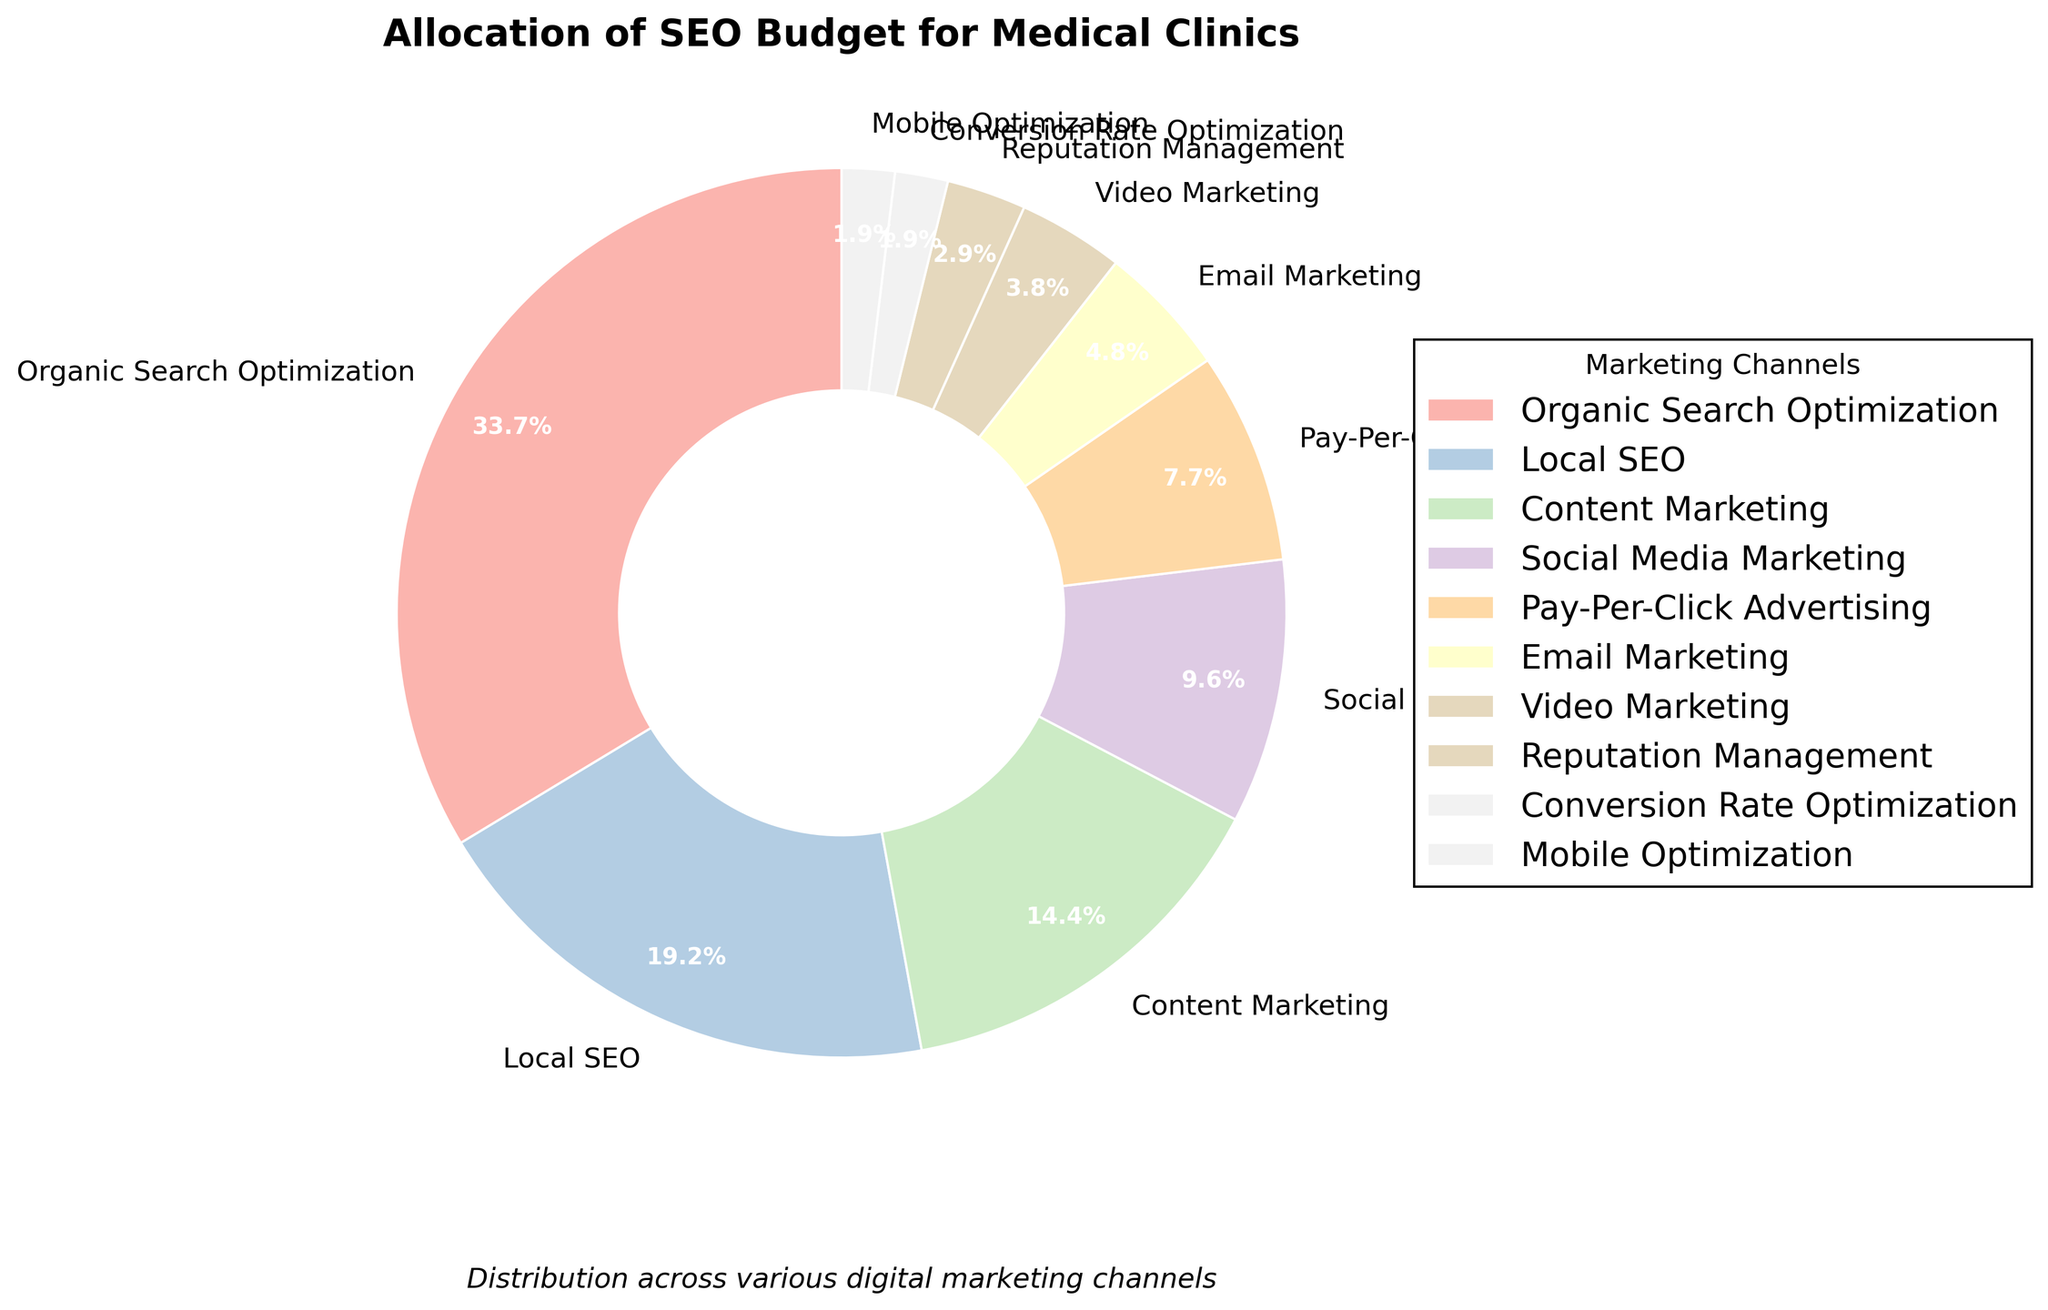What is the largest allocation percentage and which marketing channel does it correspond to? The largest allocation percentage is directly visible on the pie chart and can be seen in the section with the highest numerical label. This corresponds to Organic Search Optimization at 35%.
Answer: 35%, Organic Search Optimization Which marketing channel has the smallest allocation percentage? By looking at the smallest segment in the pie chart, we can see that the segment corresponding to the smallest percentage has a label of 2%. There are two channels with this percentage: Conversion Rate Optimization and Mobile Optimization.
Answer: Conversion Rate Optimization, Mobile Optimization How much budget, in percentage, is allocated to Local SEO and Content Marketing combined? To find the combined allocation, sum the percentages for Local SEO (20%) and Content Marketing (15%). 20% + 15% = 35%
Answer: 35% Does Social Media Marketing receive a higher budget allocation than Email Marketing? By examining the pie chart, we can compare the percentages for Social Media Marketing (10%) and Email Marketing (5%). Since 10% > 5%, Social Media Marketing receives a higher allocation.
Answer: Yes What is the difference in budget allocation between Pay-Per-Click Advertising and Video Marketing? To find the difference, subtract the percentage of Video Marketing (4%) from the percentage of Pay-Per-Click Advertising (8%). 8% - 4% = 4%
Answer: 4% Rank the top three marketing channels in terms of budget allocation. By looking at the segments with the largest percentages, we can rank them: 1) Organic Search Optimization (35%), 2) Local SEO (20%), 3) Content Marketing (15%).
Answer: 1) Organic Search Optimization, 2) Local SEO, 3) Content Marketing Is the combined allocation for Pay-Per-Click Advertising and Social Media Marketing greater than the allocation for Local SEO? Sum the percentages of Pay-Per-Click Advertising (8%) and Social Media Marketing (10%) to get 18%. Compare this with Local SEO (20%). Since 18% < 20%, it is not greater.
Answer: No What percentage of the SEO budget is allocated to channels other than Organic Search Optimization, Local SEO, and Content Marketing? First, sum the percentages for the three specified channels: 35% (Organic Search Optimization) + 20% (Local SEO) + 15% (Content Marketing) = 70%. Subtract this from 100% to find the remaining percentage. 100% - 70% = 30%.
Answer: 30% How does the allocation for Mobile Optimization compare to Reputation Management? By comparing the percentages, we can see that Mobile Optimization has a 2% allocation, which is less than Reputation Management at 3%.
Answer: Less What is the total percentage allocation for channels that receive less than 10% of the budget each? Add the percentages for Pay-Per-Click Advertising (8%), Email Marketing (5%), Video Marketing (4%), Reputation Management (3%), Conversion Rate Optimization (2%), and Mobile Optimization (2%). 8% + 5% + 4% + 3% + 2% + 2% = 24%.
Answer: 24% 